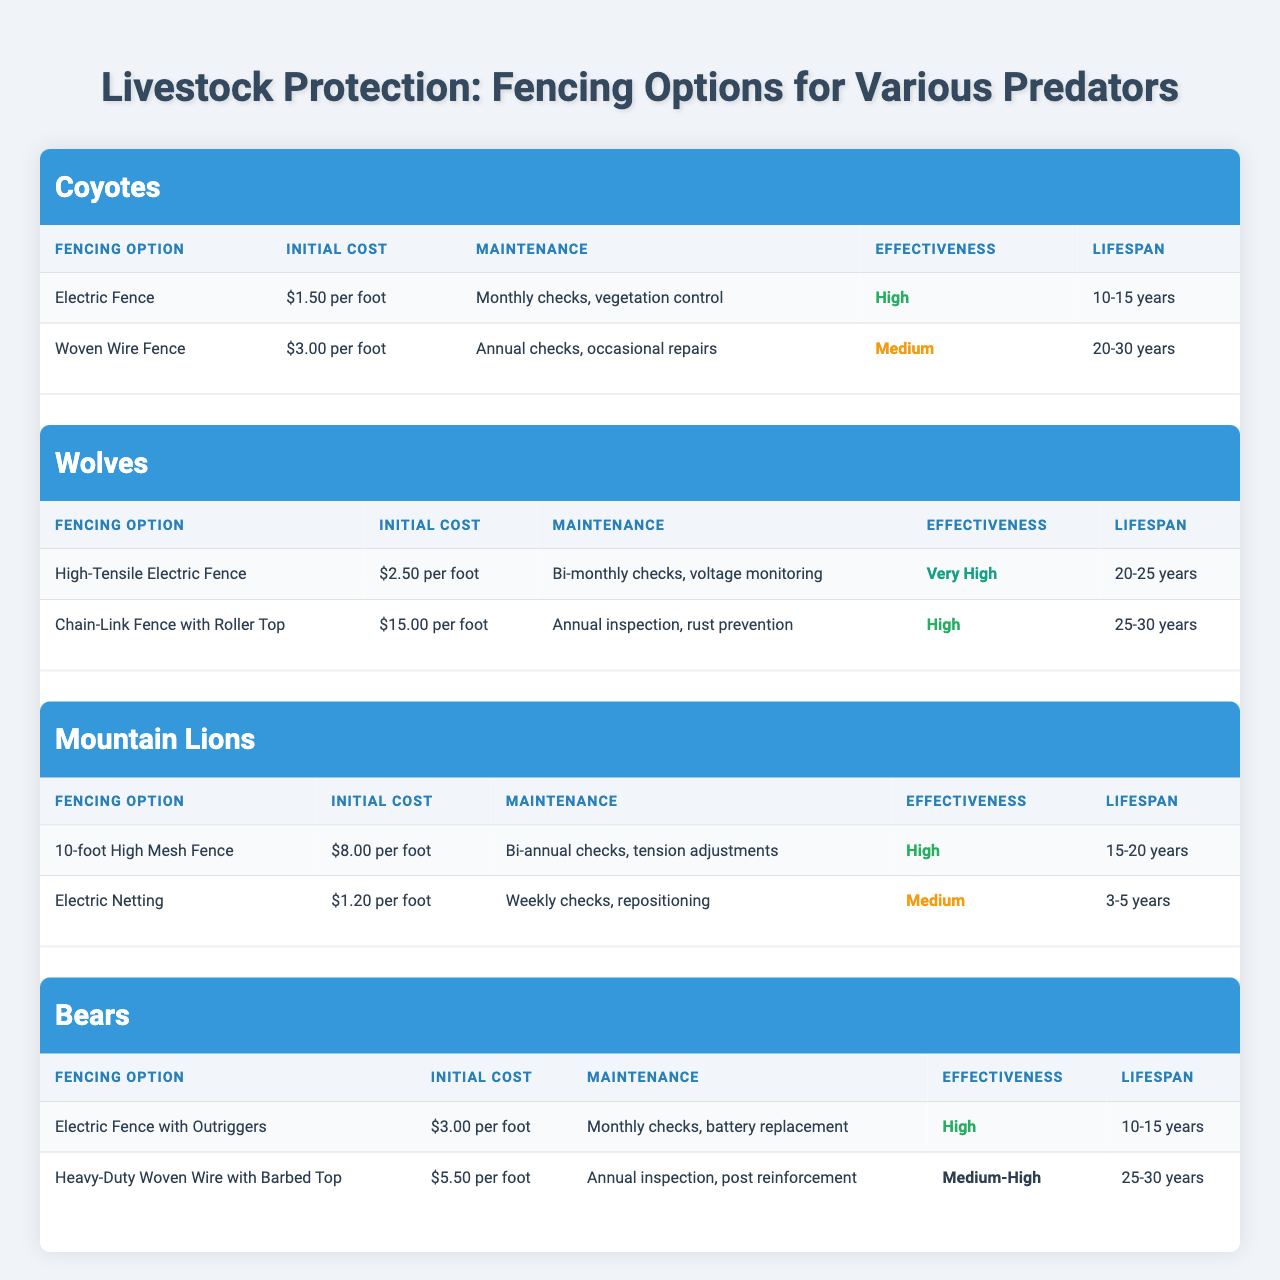What is the effectiveness level of the Electric Fence option against Coyotes? The table shows that the Electric Fence option for Coyotes has an effectiveness labeled as "High."
Answer: High What is the lifespan of the Woven Wire Fence for Coyotes? According to the table, the Woven Wire Fence has a lifespan of "20-30 years."
Answer: 20-30 years Which predator type has the highest initial cost fencing option? Looking at the table, the Chain-Link Fence with Roller Top for Wolves has the highest initial cost at "$15.00 per foot."
Answer: $15.00 per foot How often do you need to check the maintenance for the Electric Netting against Mountain Lions? The table indicates that Electric Netting requires weekly checks as part of its maintenance.
Answer: Weekly checks Which fencing option for Bears has the longest lifespan? The Heavy-Duty Woven Wire with Barbed Top has a lifespan of "25-30 years," making it the longest when compared to the Electric Fence with Outriggers which lasts "10-15 years."
Answer: 25-30 years What is the average initial cost of fencing options for Wolves? The initial costs for fencing options for Wolves are $2.50 (High-Tensile Electric Fence) and $15.00 (Chain-Link Fence with Roller Top). Summing these costs gives $17.50, and dividing by 2 options results in an average of $8.75.
Answer: $8.75 Which fencing option against Coyotes has lower maintenance, and what is it? Electric Fence requires monthly checks, while Woven Wire requires annual checks. Since annual checks are less frequent than monthly checks, the Woven Wire Fence has lower maintenance.
Answer: Woven Wire Fence Is Electric Netting a more effective option than Woven Wire Fence against Coyotes? Electric Netting has a "Medium" effectiveness, while Woven Wire Fence has a "Medium" effectiveness as well. Since they are rated equally, the answer is no, they are not different.
Answer: No How does the lifespan of the Electric Fence with Outriggers for Bears compare to that of the Electric Netting for Mountain Lions? The Electric Fence with Outriggers lasts "10-15 years," while Electric Netting lasts "3-5 years." Thus, the Electric Fence with Outriggers has a longer lifespan than Electric Netting.
Answer: Longer What is the total maintenance frequency for a Woven Wire Fence against Coyotes over its lifespan? Maintenance is annual (once a year). For a lifespan of 20-30 years, the total maintenance frequency would range between 20 to 30 checks over its lifespan.
Answer: 20-30 checks 